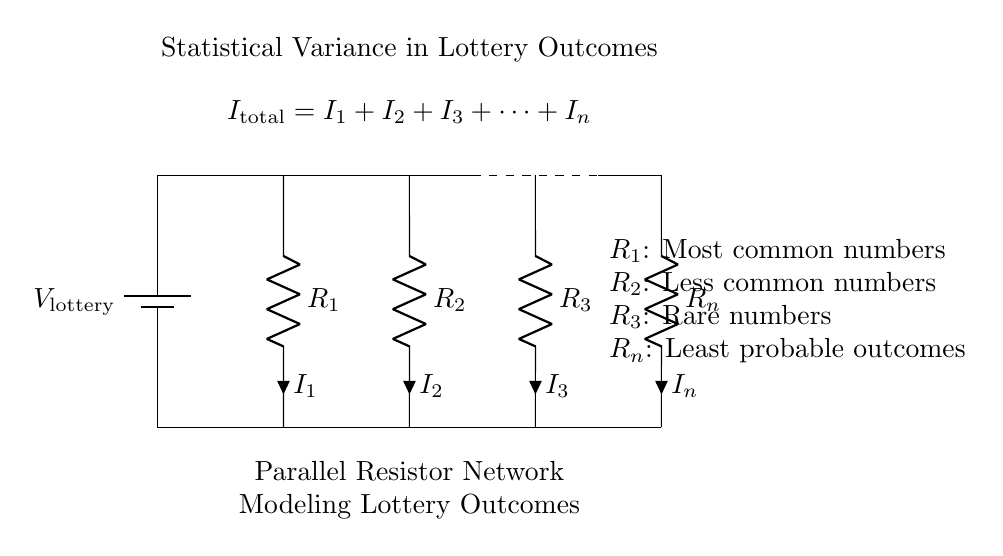What is the total current entering the circuit? The total current is represented by the equation at the top of the diagram, where the total current is the sum of the individual currents through each resistor (I_total = I_1 + I_2 + I_3 + ... + I_n).
Answer: I_total Which resistor represents the most common lottery numbers? In the diagram, the resistor labeled R_1 corresponds to the most common numbers according to the accompanying description.
Answer: R_1 How many resistors are there in this circuit? The circuit diagram shows a total of n resistors, with R_1 through R_n labeled in the visual representation.
Answer: n What does the dashed line connecting R_2 and R_3 represent? The dashed line illustrates the connections between the resistors, indicating that R_2 and R_3 are part of the same parallel branch of the circuit.
Answer: Connection between R_2 and R_3 What is implied about the behavior of current in this parallel network? The circuit operates as a current divider; therefore, the current flowing through each resistor is inversely proportional to its resistance. This means that lower resistance receives a larger share of the total current.
Answer: Current divider Which resistor likely carries the least current based on the diagram's labels? Since R_n is labeled as representing the least probable outcomes, it implies that it will carry the least current compared to the other resistors due to the current divider behavior.
Answer: R_n 